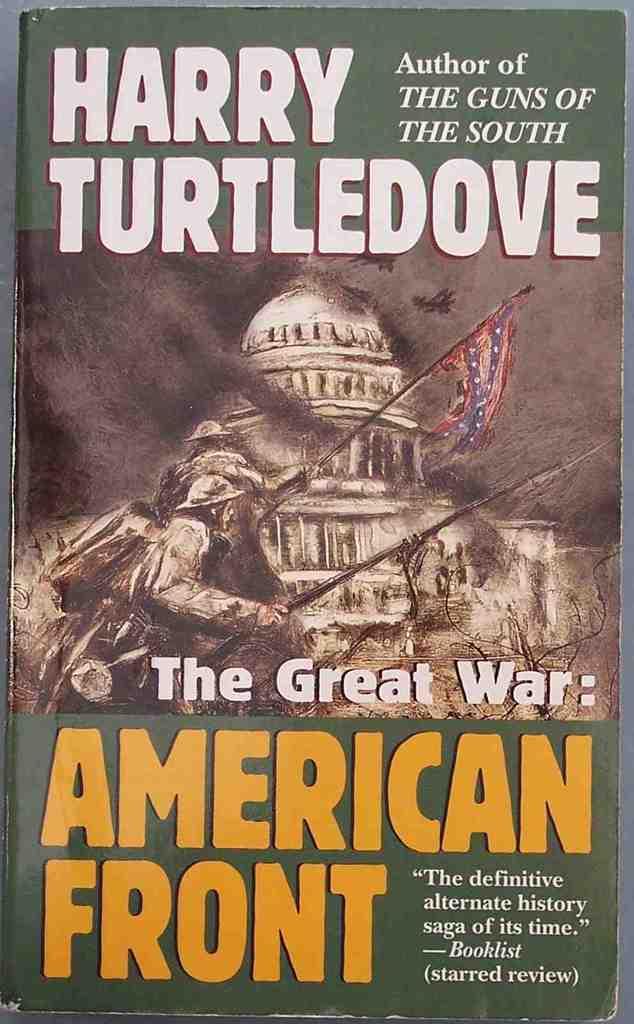Who wrote this book?
Ensure brevity in your answer.  Harry turtledove. What is the book about?
Make the answer very short. The great war. 